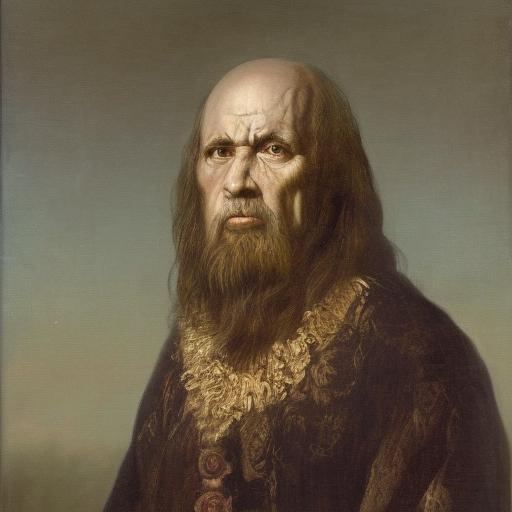What is the emotional tone conveyed by the subject's expression? The subject's expression is quite stern and intense, with a serious gaze that suggests a person of authority or deep thought, often typical of portraiture aiming to convey gravitas. Does the portrait's style give any clues about the artist or the subject's identity? The painting's realistic style and attention to texture and detail reflect techniques that were valued during the Renaissance period. However, without specific identifiers, it's difficult to ascertain the exact artist or the subject's identity based solely on style. 